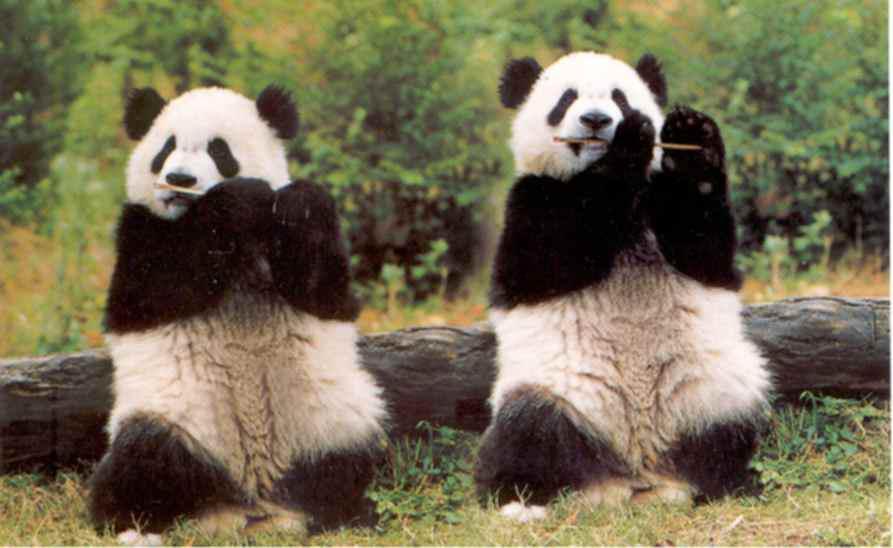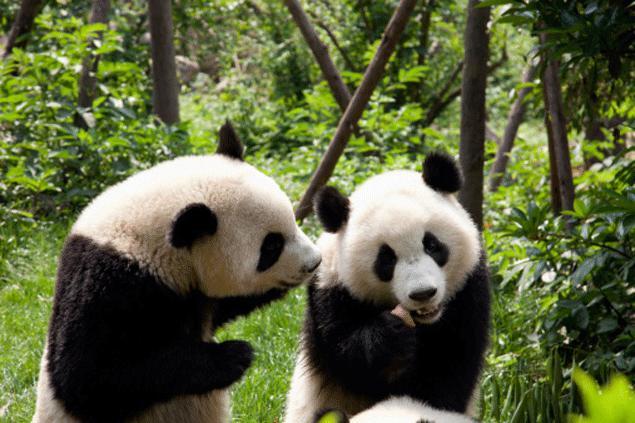The first image is the image on the left, the second image is the image on the right. Evaluate the accuracy of this statement regarding the images: "An image contains a single panda bear, which lies on its back with at least two paws off the ground.". Is it true? Answer yes or no. No. The first image is the image on the left, the second image is the image on the right. Evaluate the accuracy of this statement regarding the images: "Two pandas are sitting to eat in at least one of the images.". Is it true? Answer yes or no. Yes. 